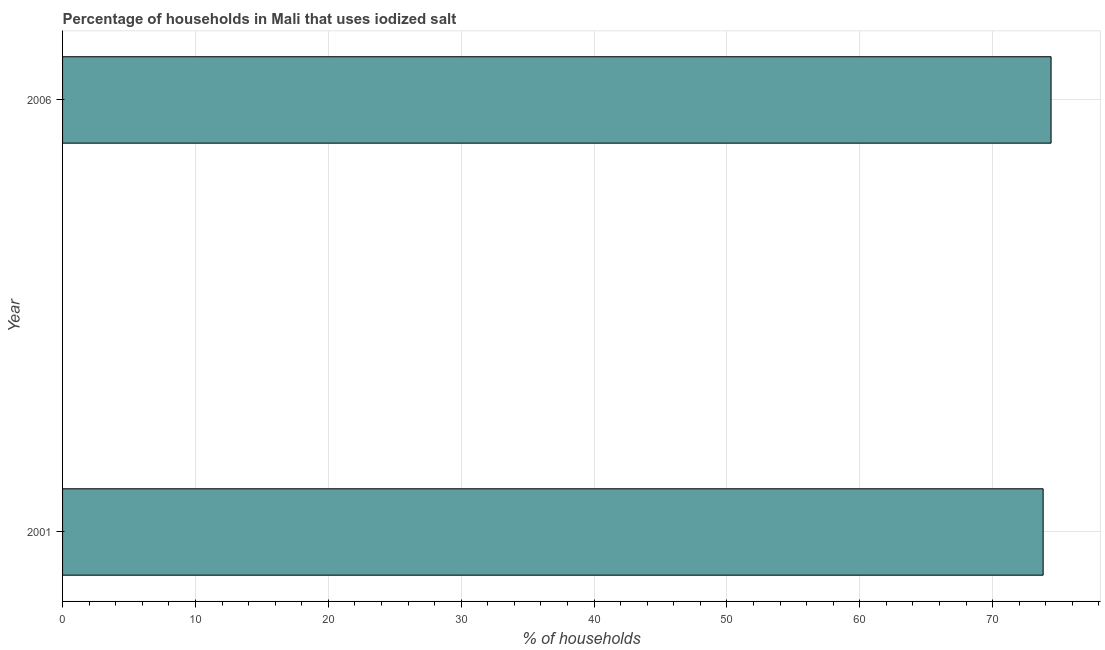What is the title of the graph?
Give a very brief answer. Percentage of households in Mali that uses iodized salt. What is the label or title of the X-axis?
Your answer should be very brief. % of households. What is the percentage of households where iodized salt is consumed in 2006?
Provide a succinct answer. 74.4. Across all years, what is the maximum percentage of households where iodized salt is consumed?
Keep it short and to the point. 74.4. Across all years, what is the minimum percentage of households where iodized salt is consumed?
Provide a short and direct response. 73.8. In which year was the percentage of households where iodized salt is consumed minimum?
Your response must be concise. 2001. What is the sum of the percentage of households where iodized salt is consumed?
Provide a short and direct response. 148.2. What is the difference between the percentage of households where iodized salt is consumed in 2001 and 2006?
Offer a very short reply. -0.6. What is the average percentage of households where iodized salt is consumed per year?
Provide a short and direct response. 74.1. What is the median percentage of households where iodized salt is consumed?
Give a very brief answer. 74.1. Do a majority of the years between 2001 and 2006 (inclusive) have percentage of households where iodized salt is consumed greater than 68 %?
Provide a succinct answer. Yes. In how many years, is the percentage of households where iodized salt is consumed greater than the average percentage of households where iodized salt is consumed taken over all years?
Your response must be concise. 1. How many years are there in the graph?
Keep it short and to the point. 2. What is the difference between two consecutive major ticks on the X-axis?
Ensure brevity in your answer.  10. Are the values on the major ticks of X-axis written in scientific E-notation?
Your answer should be compact. No. What is the % of households of 2001?
Ensure brevity in your answer.  73.8. What is the % of households of 2006?
Offer a very short reply. 74.4. What is the difference between the % of households in 2001 and 2006?
Offer a very short reply. -0.6. 